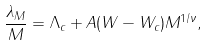Convert formula to latex. <formula><loc_0><loc_0><loc_500><loc_500>\frac { \lambda _ { M } } { M } = \Lambda _ { c } + A ( W - W _ { c } ) M ^ { 1 / \nu } ,</formula> 